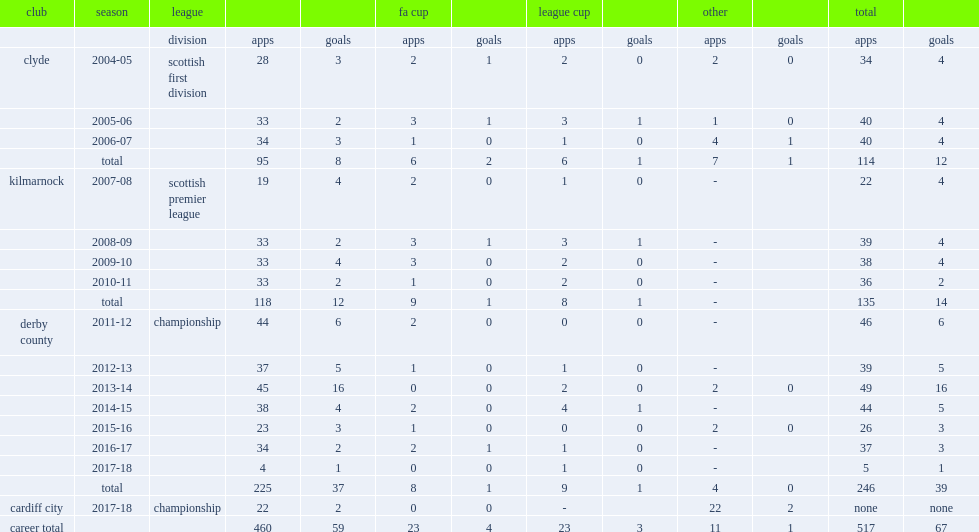How many goals did bryson score for clyde totally? 12.0. 